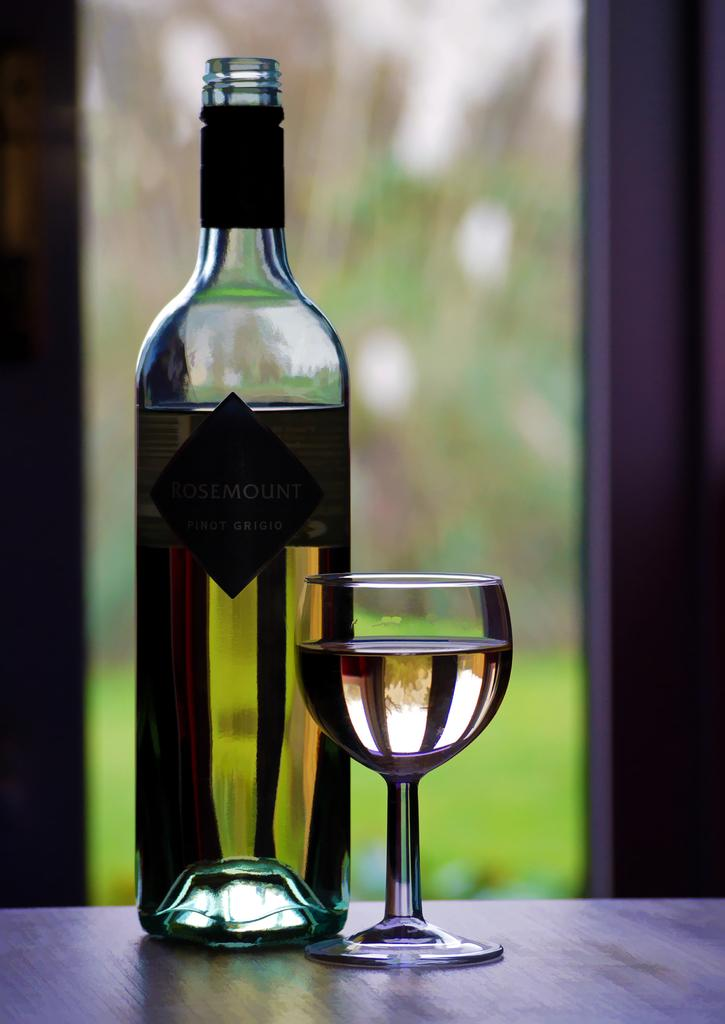What piece of furniture is present in the image? There is a table in the image. What is placed on the table? There is a wine bottle and a wine glass filled with wine on the table. What might be used for drinking the wine in the image? The wine glass filled with wine on the table can be used for drinking. Where is the popcorn stored in the image? There is no popcorn present in the image. What type of calendar is visible on the table in the image? There is no calendar present in the image. 